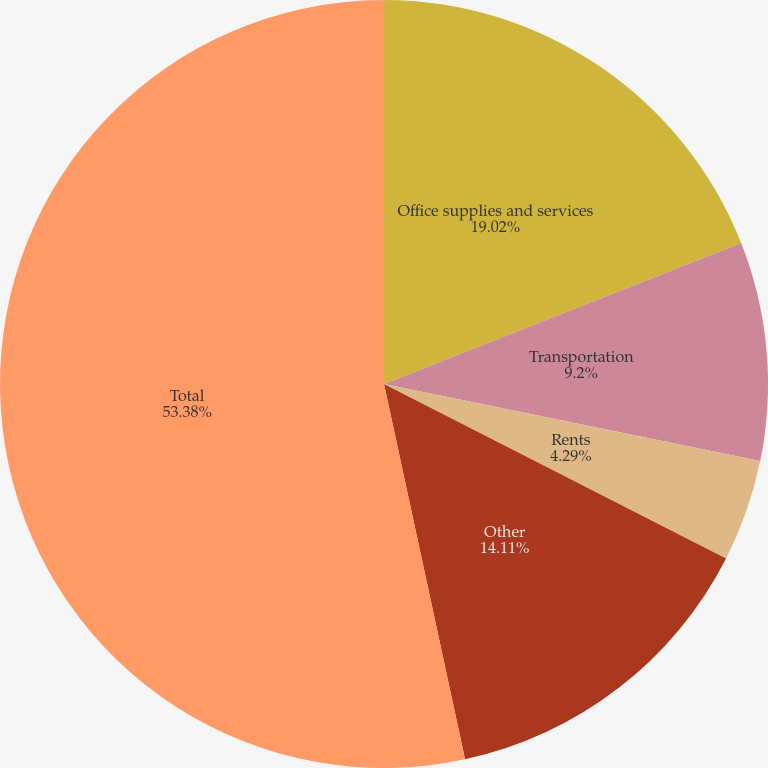<chart> <loc_0><loc_0><loc_500><loc_500><pie_chart><fcel>Office supplies and services<fcel>Transportation<fcel>Rents<fcel>Other<fcel>Total<nl><fcel>19.02%<fcel>9.2%<fcel>4.29%<fcel>14.11%<fcel>53.39%<nl></chart> 